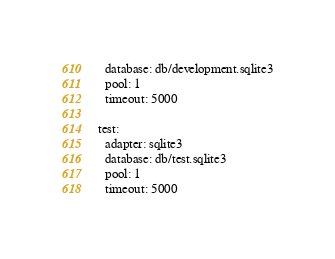Convert code to text. <code><loc_0><loc_0><loc_500><loc_500><_YAML_>  database: db/development.sqlite3
  pool: 1
  timeout: 5000

test:
  adapter: sqlite3
  database: db/test.sqlite3
  pool: 1
  timeout: 5000
</code> 